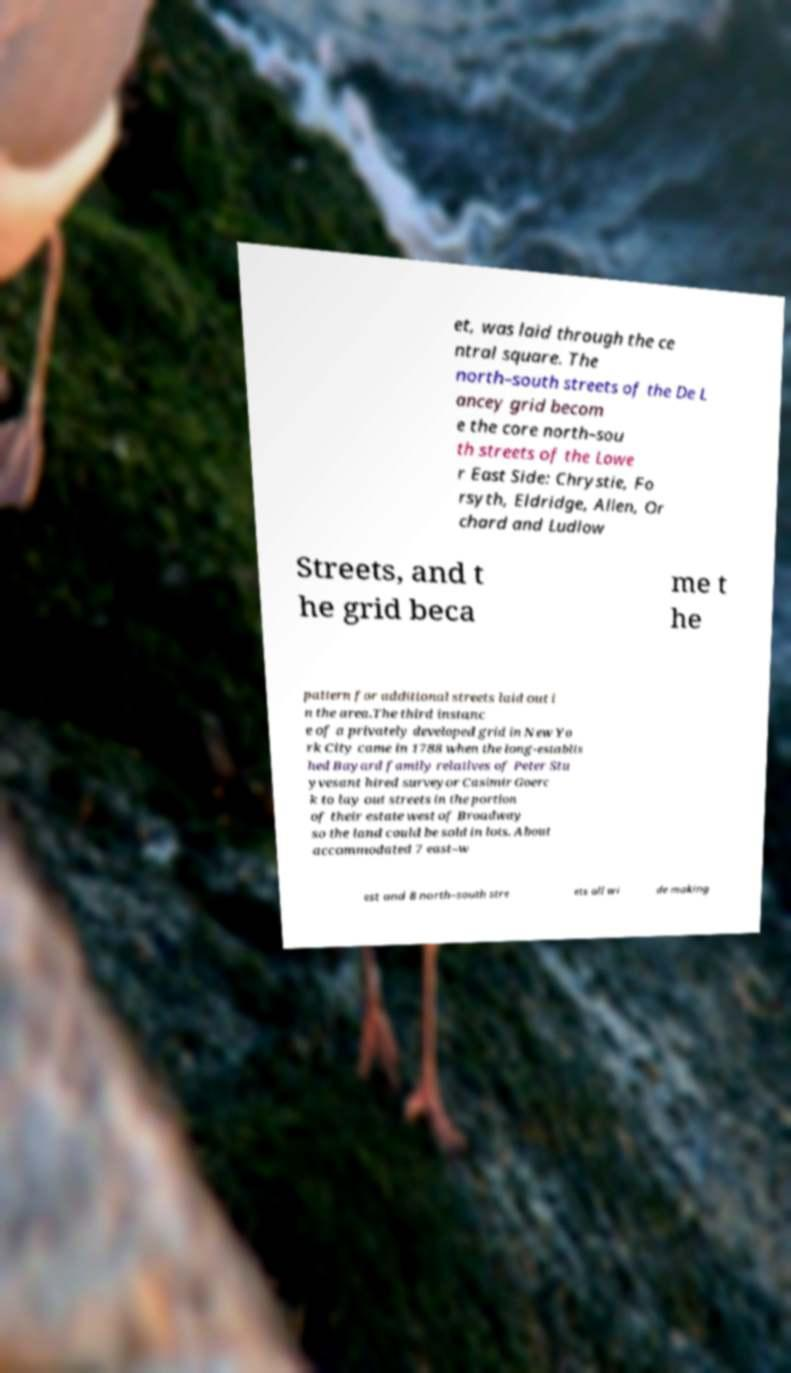Can you read and provide the text displayed in the image?This photo seems to have some interesting text. Can you extract and type it out for me? et, was laid through the ce ntral square. The north–south streets of the De L ancey grid becom e the core north–sou th streets of the Lowe r East Side: Chrystie, Fo rsyth, Eldridge, Allen, Or chard and Ludlow Streets, and t he grid beca me t he pattern for additional streets laid out i n the area.The third instanc e of a privately developed grid in New Yo rk City came in 1788 when the long-establis hed Bayard family relatives of Peter Stu yvesant hired surveyor Casimir Goerc k to lay out streets in the portion of their estate west of Broadway so the land could be sold in lots. About accommodated 7 east–w est and 8 north–south stre ets all wi de making 